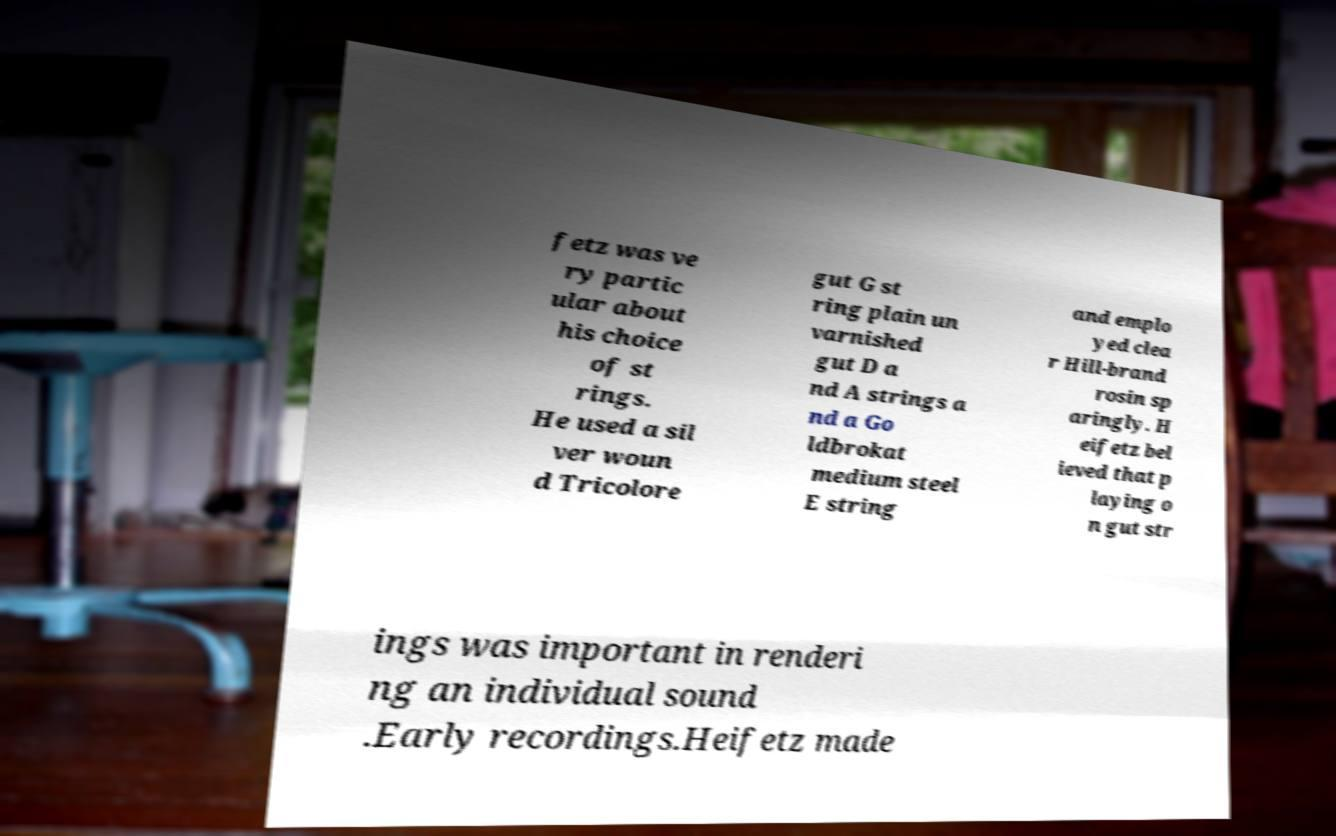There's text embedded in this image that I need extracted. Can you transcribe it verbatim? fetz was ve ry partic ular about his choice of st rings. He used a sil ver woun d Tricolore gut G st ring plain un varnished gut D a nd A strings a nd a Go ldbrokat medium steel E string and emplo yed clea r Hill-brand rosin sp aringly. H eifetz bel ieved that p laying o n gut str ings was important in renderi ng an individual sound .Early recordings.Heifetz made 